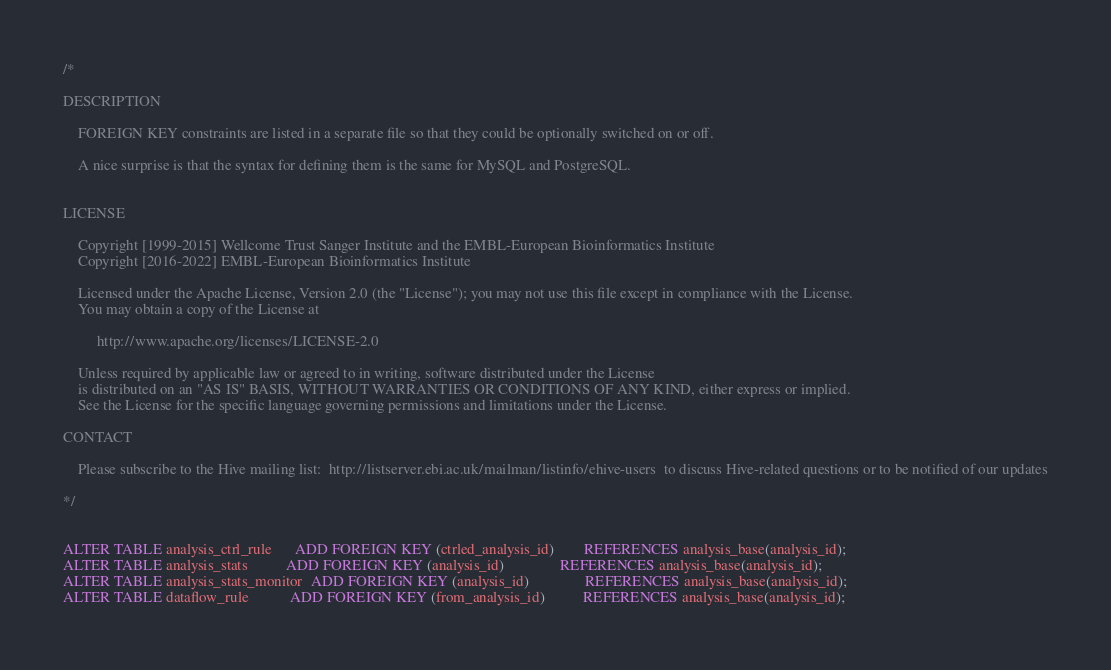<code> <loc_0><loc_0><loc_500><loc_500><_SQL_>/*

DESCRIPTION

    FOREIGN KEY constraints are listed in a separate file so that they could be optionally switched on or off.

    A nice surprise is that the syntax for defining them is the same for MySQL and PostgreSQL.


LICENSE

    Copyright [1999-2015] Wellcome Trust Sanger Institute and the EMBL-European Bioinformatics Institute
    Copyright [2016-2022] EMBL-European Bioinformatics Institute

    Licensed under the Apache License, Version 2.0 (the "License"); you may not use this file except in compliance with the License.
    You may obtain a copy of the License at

         http://www.apache.org/licenses/LICENSE-2.0

    Unless required by applicable law or agreed to in writing, software distributed under the License
    is distributed on an "AS IS" BASIS, WITHOUT WARRANTIES OR CONDITIONS OF ANY KIND, either express or implied.
    See the License for the specific language governing permissions and limitations under the License.

CONTACT

    Please subscribe to the Hive mailing list:  http://listserver.ebi.ac.uk/mailman/listinfo/ehive-users  to discuss Hive-related questions or to be notified of our updates

*/


ALTER TABLE analysis_ctrl_rule      ADD FOREIGN KEY (ctrled_analysis_id)        REFERENCES analysis_base(analysis_id);
ALTER TABLE analysis_stats          ADD FOREIGN KEY (analysis_id)               REFERENCES analysis_base(analysis_id);
ALTER TABLE analysis_stats_monitor  ADD FOREIGN KEY (analysis_id)               REFERENCES analysis_base(analysis_id);
ALTER TABLE dataflow_rule           ADD FOREIGN KEY (from_analysis_id)          REFERENCES analysis_base(analysis_id);</code> 